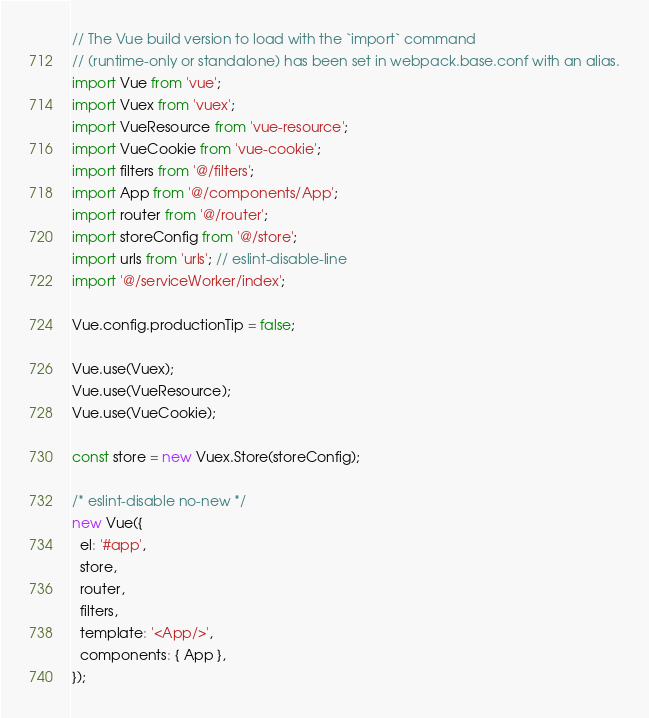<code> <loc_0><loc_0><loc_500><loc_500><_JavaScript_>// The Vue build version to load with the `import` command
// (runtime-only or standalone) has been set in webpack.base.conf with an alias.
import Vue from 'vue';
import Vuex from 'vuex';
import VueResource from 'vue-resource';
import VueCookie from 'vue-cookie';
import filters from '@/filters';
import App from '@/components/App';
import router from '@/router';
import storeConfig from '@/store';
import urls from 'urls'; // eslint-disable-line
import '@/serviceWorker/index';

Vue.config.productionTip = false;

Vue.use(Vuex);
Vue.use(VueResource);
Vue.use(VueCookie);

const store = new Vuex.Store(storeConfig);

/* eslint-disable no-new */
new Vue({
  el: '#app',
  store,
  router,
  filters,
  template: '<App/>',
  components: { App },
});
</code> 